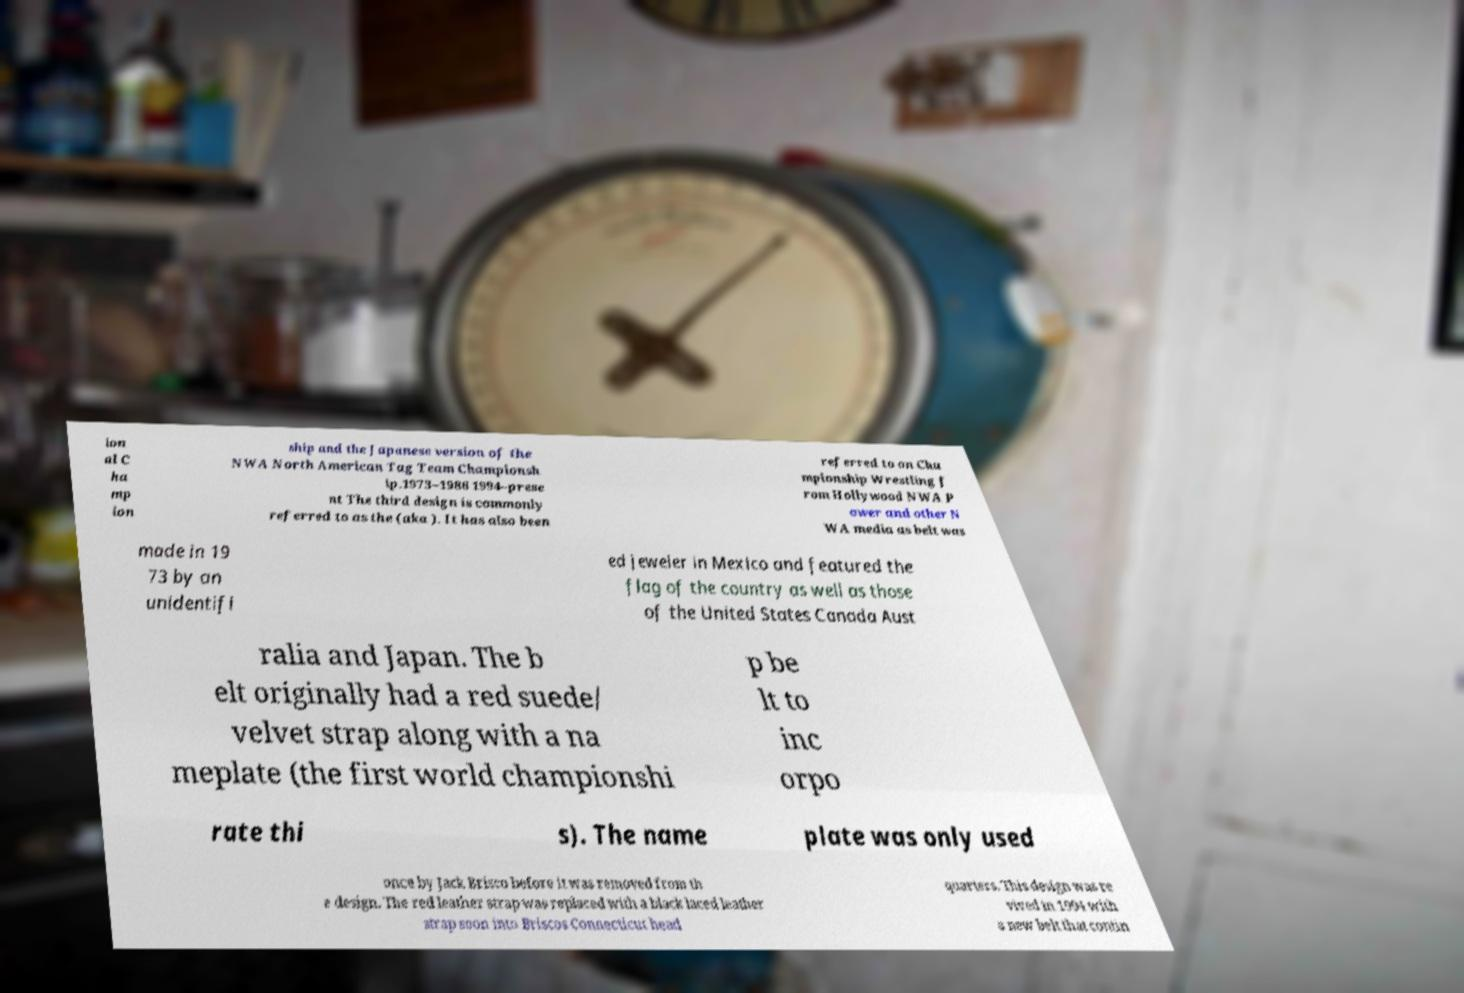Could you extract and type out the text from this image? ion al C ha mp ion ship and the Japanese version of the NWA North American Tag Team Championsh ip.1973–1986 1994–prese nt The third design is commonly referred to as the (aka ). It has also been referred to on Cha mpionship Wrestling f rom Hollywood NWA P ower and other N WA media as belt was made in 19 73 by an unidentifi ed jeweler in Mexico and featured the flag of the country as well as those of the United States Canada Aust ralia and Japan. The b elt originally had a red suede/ velvet strap along with a na meplate (the first world championshi p be lt to inc orpo rate thi s). The name plate was only used once by Jack Brisco before it was removed from th e design. The red leather strap was replaced with a black laced leather strap soon into Briscos Connecticut head quarters. This design was re vived in 1994 with a new belt that contin 